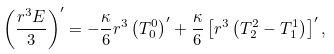<formula> <loc_0><loc_0><loc_500><loc_500>\left ( \frac { r ^ { 3 } E } { 3 } \right ) ^ { \prime } = - \frac { \kappa } { 6 } r ^ { 3 } \left ( T ^ { 0 } _ { 0 } \right ) ^ { \prime } + \frac { \kappa } { 6 } \left [ r ^ { 3 } \left ( T ^ { 2 } _ { 2 } - T ^ { 1 } _ { 1 } \right ) \right ] ^ { \prime } ,</formula> 